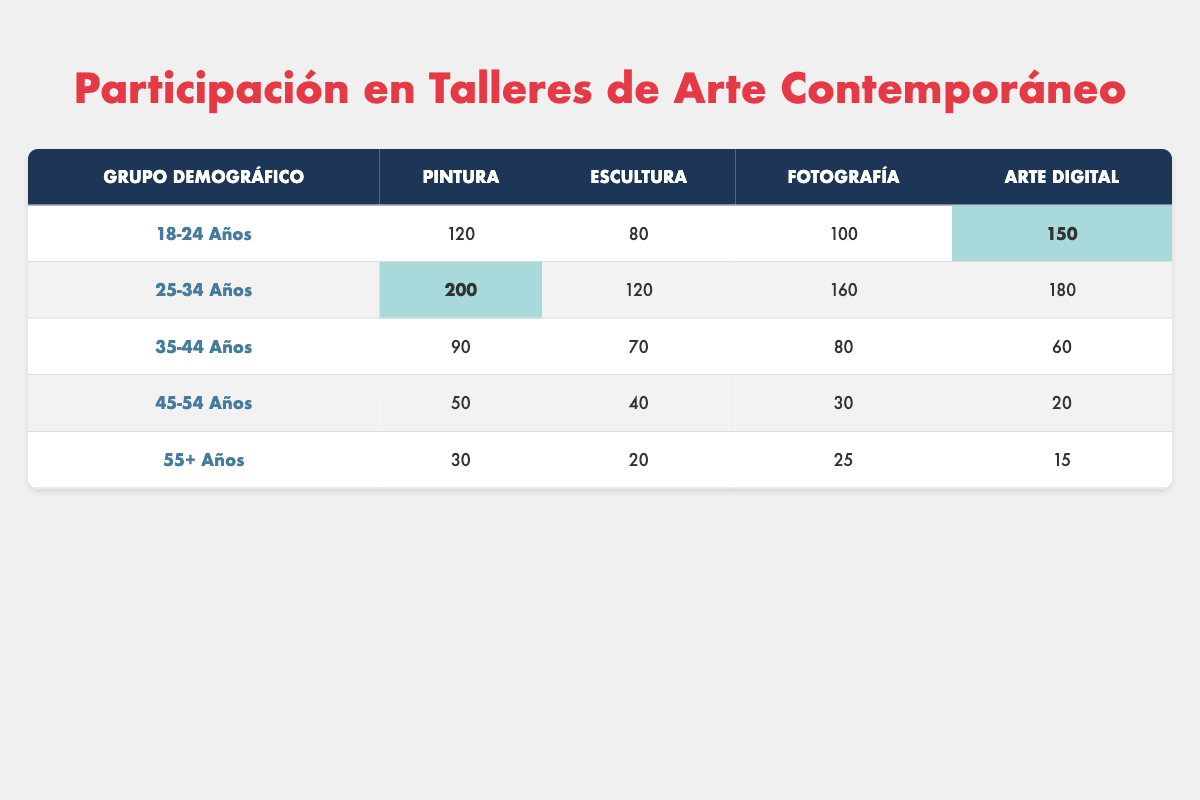How many people aged 18-24 participated in digital art workshops? In the row for the demographic group "18-24 Años," the column for "Arte Digital" shows the value 150. Hence, 150 people participated in digital art workshops within this age group.
Answer: 150 What is the total number of participants in sculpture workshops across all age groups? To find the total for sculpture, add the values: 80 (18-24) + 120 (25-34) + 70 (35-44) + 40 (45-54) + 20 (55+) = 400. Therefore, the total number of participants in sculpture workshops is 400.
Answer: 400 Is it true that more people aged 35-44 participated in photography workshops than in sculpture workshops? In the row for "35-44 Años," the value for "Fotografía" is 80, and for "Escultura," it is 70. Since 80 (Fotografía) is greater than 70 (Escultura), the statement is true.
Answer: Yes What is the average number of participants in painting workshops across all age groups? The total number of participants in painting is 120 (18-24) + 200 (25-34) + 90 (35-44) + 50 (45-54) + 30 (55+) = 490. There are 5 age groups, so the average is 490 / 5 = 98.
Answer: 98 For which age group is the highest participation in sculpture workshops, and how many participated? Looking at the table, the highest value for "Escultura" is 120 for the age group "25-34 Años." Thus, the highest participation in sculpture workshops is 120 from that age group.
Answer: 120 (25-34 Años) How many fewer people participated in digital art workshops than in painting workshops for those aged 55 and above? For the age group "55+ Años," there were 15 participants in digital art and 30 in painting. The difference is 30 (painting) - 15 (digital art) = 15. Thus, 15 fewer people participated in digital art workshops compared to painting workshops for this age group.
Answer: 15 Which demographic group had the least participation in photography workshops, and how many participated? In the photography column, the lowest value is 25, which corresponds to the "55+ Años" demographic group. Therefore, the least participation in photography workshops was from this group with 25 participants.
Answer: 25 (55+ Años) 